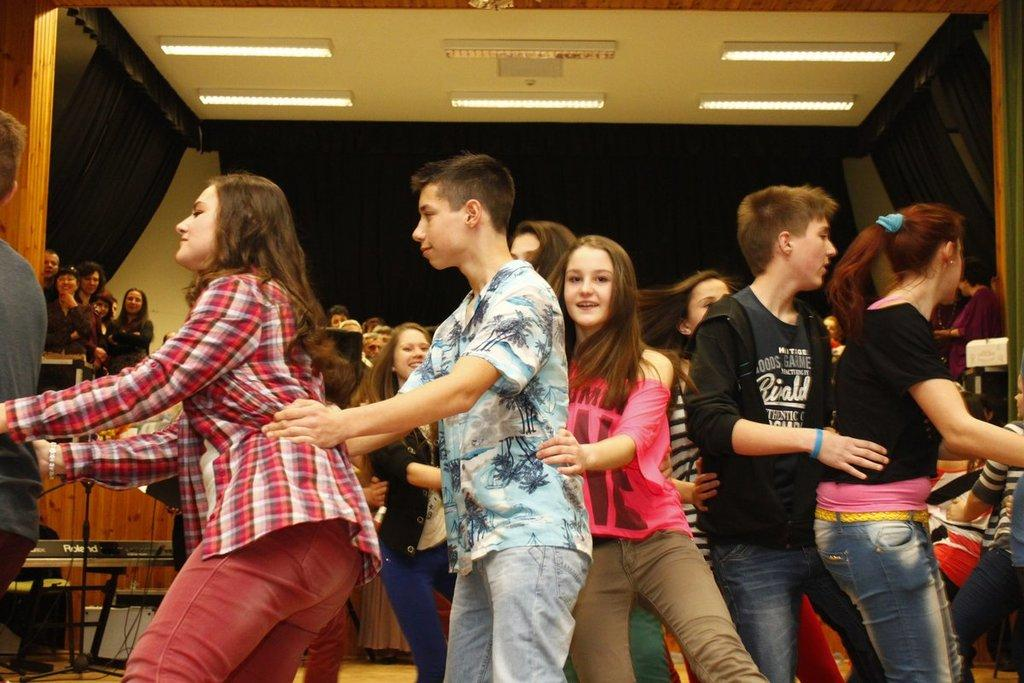How many people are in the image? There is a group of people in the image. What can be observed about the clothing of the people in the image? The people are wearing different color dresses. What else can be seen in the image besides the people? There are objects and lights visible in the image. What type of architectural feature is present in the image? There is a wall in the image. What might be used to control the amount of light entering the room in the image? Curtains are present in the image. What type of cloth is used to expand the space in the image? There is no cloth used to expand the space in the image. 